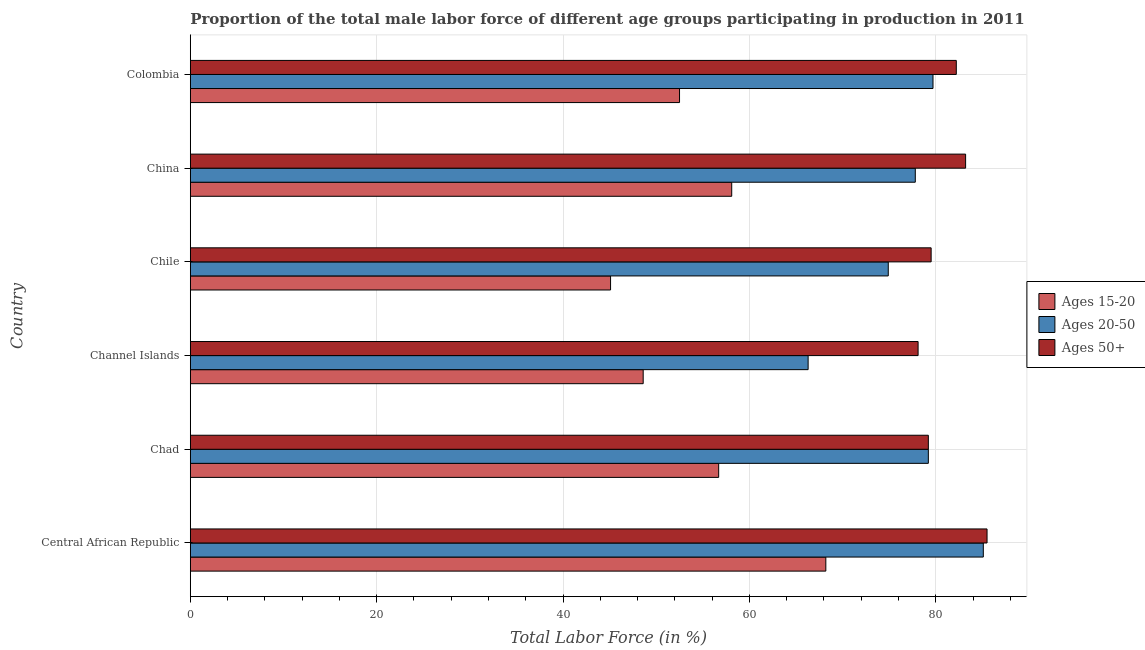How many bars are there on the 1st tick from the top?
Offer a terse response. 3. In how many cases, is the number of bars for a given country not equal to the number of legend labels?
Your response must be concise. 0. What is the percentage of male labor force within the age group 15-20 in Colombia?
Your answer should be very brief. 52.5. Across all countries, what is the maximum percentage of male labor force above age 50?
Make the answer very short. 85.5. Across all countries, what is the minimum percentage of male labor force above age 50?
Give a very brief answer. 78.1. In which country was the percentage of male labor force within the age group 15-20 maximum?
Keep it short and to the point. Central African Republic. In which country was the percentage of male labor force within the age group 20-50 minimum?
Your answer should be compact. Channel Islands. What is the total percentage of male labor force above age 50 in the graph?
Provide a succinct answer. 487.7. What is the difference between the percentage of male labor force above age 50 in Central African Republic and the percentage of male labor force within the age group 20-50 in Channel Islands?
Give a very brief answer. 19.2. What is the average percentage of male labor force within the age group 15-20 per country?
Offer a terse response. 54.87. What is the difference between the percentage of male labor force within the age group 15-20 and percentage of male labor force within the age group 20-50 in China?
Offer a very short reply. -19.7. What is the ratio of the percentage of male labor force within the age group 15-20 in Central African Republic to that in Chile?
Offer a terse response. 1.51. What is the difference between the highest and the second highest percentage of male labor force within the age group 15-20?
Make the answer very short. 10.1. What is the difference between the highest and the lowest percentage of male labor force within the age group 20-50?
Your answer should be compact. 18.8. In how many countries, is the percentage of male labor force within the age group 20-50 greater than the average percentage of male labor force within the age group 20-50 taken over all countries?
Give a very brief answer. 4. What does the 1st bar from the top in China represents?
Offer a very short reply. Ages 50+. What does the 1st bar from the bottom in China represents?
Keep it short and to the point. Ages 15-20. Is it the case that in every country, the sum of the percentage of male labor force within the age group 15-20 and percentage of male labor force within the age group 20-50 is greater than the percentage of male labor force above age 50?
Provide a short and direct response. Yes. Are all the bars in the graph horizontal?
Offer a very short reply. Yes. Does the graph contain grids?
Make the answer very short. Yes. Where does the legend appear in the graph?
Provide a short and direct response. Center right. How many legend labels are there?
Make the answer very short. 3. How are the legend labels stacked?
Make the answer very short. Vertical. What is the title of the graph?
Provide a succinct answer. Proportion of the total male labor force of different age groups participating in production in 2011. Does "Resident buildings and public services" appear as one of the legend labels in the graph?
Your answer should be compact. No. What is the label or title of the X-axis?
Offer a very short reply. Total Labor Force (in %). What is the label or title of the Y-axis?
Offer a very short reply. Country. What is the Total Labor Force (in %) of Ages 15-20 in Central African Republic?
Provide a short and direct response. 68.2. What is the Total Labor Force (in %) of Ages 20-50 in Central African Republic?
Provide a short and direct response. 85.1. What is the Total Labor Force (in %) of Ages 50+ in Central African Republic?
Ensure brevity in your answer.  85.5. What is the Total Labor Force (in %) of Ages 15-20 in Chad?
Provide a succinct answer. 56.7. What is the Total Labor Force (in %) of Ages 20-50 in Chad?
Provide a short and direct response. 79.2. What is the Total Labor Force (in %) in Ages 50+ in Chad?
Keep it short and to the point. 79.2. What is the Total Labor Force (in %) of Ages 15-20 in Channel Islands?
Offer a very short reply. 48.6. What is the Total Labor Force (in %) of Ages 20-50 in Channel Islands?
Offer a very short reply. 66.3. What is the Total Labor Force (in %) of Ages 50+ in Channel Islands?
Your answer should be very brief. 78.1. What is the Total Labor Force (in %) of Ages 15-20 in Chile?
Keep it short and to the point. 45.1. What is the Total Labor Force (in %) in Ages 20-50 in Chile?
Provide a succinct answer. 74.9. What is the Total Labor Force (in %) of Ages 50+ in Chile?
Keep it short and to the point. 79.5. What is the Total Labor Force (in %) of Ages 15-20 in China?
Offer a very short reply. 58.1. What is the Total Labor Force (in %) of Ages 20-50 in China?
Ensure brevity in your answer.  77.8. What is the Total Labor Force (in %) of Ages 50+ in China?
Make the answer very short. 83.2. What is the Total Labor Force (in %) of Ages 15-20 in Colombia?
Ensure brevity in your answer.  52.5. What is the Total Labor Force (in %) of Ages 20-50 in Colombia?
Provide a succinct answer. 79.7. What is the Total Labor Force (in %) of Ages 50+ in Colombia?
Your answer should be very brief. 82.2. Across all countries, what is the maximum Total Labor Force (in %) in Ages 15-20?
Provide a short and direct response. 68.2. Across all countries, what is the maximum Total Labor Force (in %) in Ages 20-50?
Your response must be concise. 85.1. Across all countries, what is the maximum Total Labor Force (in %) in Ages 50+?
Your answer should be compact. 85.5. Across all countries, what is the minimum Total Labor Force (in %) in Ages 15-20?
Your answer should be compact. 45.1. Across all countries, what is the minimum Total Labor Force (in %) in Ages 20-50?
Ensure brevity in your answer.  66.3. Across all countries, what is the minimum Total Labor Force (in %) of Ages 50+?
Provide a succinct answer. 78.1. What is the total Total Labor Force (in %) of Ages 15-20 in the graph?
Your answer should be very brief. 329.2. What is the total Total Labor Force (in %) of Ages 20-50 in the graph?
Make the answer very short. 463. What is the total Total Labor Force (in %) in Ages 50+ in the graph?
Ensure brevity in your answer.  487.7. What is the difference between the Total Labor Force (in %) in Ages 15-20 in Central African Republic and that in Chad?
Give a very brief answer. 11.5. What is the difference between the Total Labor Force (in %) in Ages 20-50 in Central African Republic and that in Chad?
Your answer should be compact. 5.9. What is the difference between the Total Labor Force (in %) of Ages 50+ in Central African Republic and that in Chad?
Provide a succinct answer. 6.3. What is the difference between the Total Labor Force (in %) of Ages 15-20 in Central African Republic and that in Channel Islands?
Ensure brevity in your answer.  19.6. What is the difference between the Total Labor Force (in %) of Ages 15-20 in Central African Republic and that in Chile?
Ensure brevity in your answer.  23.1. What is the difference between the Total Labor Force (in %) in Ages 20-50 in Central African Republic and that in Chile?
Provide a succinct answer. 10.2. What is the difference between the Total Labor Force (in %) of Ages 15-20 in Central African Republic and that in China?
Your answer should be compact. 10.1. What is the difference between the Total Labor Force (in %) in Ages 20-50 in Central African Republic and that in China?
Offer a very short reply. 7.3. What is the difference between the Total Labor Force (in %) in Ages 20-50 in Central African Republic and that in Colombia?
Provide a short and direct response. 5.4. What is the difference between the Total Labor Force (in %) in Ages 15-20 in Chad and that in Channel Islands?
Offer a very short reply. 8.1. What is the difference between the Total Labor Force (in %) of Ages 20-50 in Chad and that in China?
Ensure brevity in your answer.  1.4. What is the difference between the Total Labor Force (in %) in Ages 50+ in Chad and that in China?
Give a very brief answer. -4. What is the difference between the Total Labor Force (in %) of Ages 15-20 in Chad and that in Colombia?
Your response must be concise. 4.2. What is the difference between the Total Labor Force (in %) of Ages 15-20 in Channel Islands and that in Chile?
Offer a terse response. 3.5. What is the difference between the Total Labor Force (in %) in Ages 15-20 in Channel Islands and that in China?
Ensure brevity in your answer.  -9.5. What is the difference between the Total Labor Force (in %) in Ages 20-50 in Channel Islands and that in China?
Keep it short and to the point. -11.5. What is the difference between the Total Labor Force (in %) in Ages 15-20 in Chile and that in China?
Provide a short and direct response. -13. What is the difference between the Total Labor Force (in %) in Ages 15-20 in Chile and that in Colombia?
Make the answer very short. -7.4. What is the difference between the Total Labor Force (in %) of Ages 15-20 in China and that in Colombia?
Offer a very short reply. 5.6. What is the difference between the Total Labor Force (in %) in Ages 20-50 in China and that in Colombia?
Provide a short and direct response. -1.9. What is the difference between the Total Labor Force (in %) of Ages 15-20 in Central African Republic and the Total Labor Force (in %) of Ages 20-50 in Chad?
Offer a very short reply. -11. What is the difference between the Total Labor Force (in %) of Ages 15-20 in Central African Republic and the Total Labor Force (in %) of Ages 50+ in Channel Islands?
Your answer should be very brief. -9.9. What is the difference between the Total Labor Force (in %) in Ages 15-20 in Central African Republic and the Total Labor Force (in %) in Ages 50+ in Chile?
Ensure brevity in your answer.  -11.3. What is the difference between the Total Labor Force (in %) in Ages 20-50 in Central African Republic and the Total Labor Force (in %) in Ages 50+ in Chile?
Your response must be concise. 5.6. What is the difference between the Total Labor Force (in %) in Ages 15-20 in Central African Republic and the Total Labor Force (in %) in Ages 20-50 in China?
Your answer should be very brief. -9.6. What is the difference between the Total Labor Force (in %) in Ages 15-20 in Central African Republic and the Total Labor Force (in %) in Ages 50+ in China?
Your answer should be compact. -15. What is the difference between the Total Labor Force (in %) of Ages 15-20 in Central African Republic and the Total Labor Force (in %) of Ages 20-50 in Colombia?
Your response must be concise. -11.5. What is the difference between the Total Labor Force (in %) of Ages 15-20 in Central African Republic and the Total Labor Force (in %) of Ages 50+ in Colombia?
Ensure brevity in your answer.  -14. What is the difference between the Total Labor Force (in %) of Ages 20-50 in Central African Republic and the Total Labor Force (in %) of Ages 50+ in Colombia?
Provide a succinct answer. 2.9. What is the difference between the Total Labor Force (in %) in Ages 15-20 in Chad and the Total Labor Force (in %) in Ages 50+ in Channel Islands?
Offer a terse response. -21.4. What is the difference between the Total Labor Force (in %) of Ages 20-50 in Chad and the Total Labor Force (in %) of Ages 50+ in Channel Islands?
Your answer should be compact. 1.1. What is the difference between the Total Labor Force (in %) in Ages 15-20 in Chad and the Total Labor Force (in %) in Ages 20-50 in Chile?
Your response must be concise. -18.2. What is the difference between the Total Labor Force (in %) of Ages 15-20 in Chad and the Total Labor Force (in %) of Ages 50+ in Chile?
Provide a succinct answer. -22.8. What is the difference between the Total Labor Force (in %) in Ages 15-20 in Chad and the Total Labor Force (in %) in Ages 20-50 in China?
Your answer should be compact. -21.1. What is the difference between the Total Labor Force (in %) in Ages 15-20 in Chad and the Total Labor Force (in %) in Ages 50+ in China?
Your answer should be compact. -26.5. What is the difference between the Total Labor Force (in %) in Ages 15-20 in Chad and the Total Labor Force (in %) in Ages 50+ in Colombia?
Ensure brevity in your answer.  -25.5. What is the difference between the Total Labor Force (in %) in Ages 15-20 in Channel Islands and the Total Labor Force (in %) in Ages 20-50 in Chile?
Give a very brief answer. -26.3. What is the difference between the Total Labor Force (in %) in Ages 15-20 in Channel Islands and the Total Labor Force (in %) in Ages 50+ in Chile?
Ensure brevity in your answer.  -30.9. What is the difference between the Total Labor Force (in %) in Ages 20-50 in Channel Islands and the Total Labor Force (in %) in Ages 50+ in Chile?
Provide a succinct answer. -13.2. What is the difference between the Total Labor Force (in %) in Ages 15-20 in Channel Islands and the Total Labor Force (in %) in Ages 20-50 in China?
Provide a short and direct response. -29.2. What is the difference between the Total Labor Force (in %) of Ages 15-20 in Channel Islands and the Total Labor Force (in %) of Ages 50+ in China?
Your answer should be compact. -34.6. What is the difference between the Total Labor Force (in %) of Ages 20-50 in Channel Islands and the Total Labor Force (in %) of Ages 50+ in China?
Your response must be concise. -16.9. What is the difference between the Total Labor Force (in %) of Ages 15-20 in Channel Islands and the Total Labor Force (in %) of Ages 20-50 in Colombia?
Give a very brief answer. -31.1. What is the difference between the Total Labor Force (in %) of Ages 15-20 in Channel Islands and the Total Labor Force (in %) of Ages 50+ in Colombia?
Provide a short and direct response. -33.6. What is the difference between the Total Labor Force (in %) of Ages 20-50 in Channel Islands and the Total Labor Force (in %) of Ages 50+ in Colombia?
Offer a terse response. -15.9. What is the difference between the Total Labor Force (in %) in Ages 15-20 in Chile and the Total Labor Force (in %) in Ages 20-50 in China?
Your answer should be compact. -32.7. What is the difference between the Total Labor Force (in %) of Ages 15-20 in Chile and the Total Labor Force (in %) of Ages 50+ in China?
Provide a succinct answer. -38.1. What is the difference between the Total Labor Force (in %) of Ages 15-20 in Chile and the Total Labor Force (in %) of Ages 20-50 in Colombia?
Your answer should be compact. -34.6. What is the difference between the Total Labor Force (in %) in Ages 15-20 in Chile and the Total Labor Force (in %) in Ages 50+ in Colombia?
Ensure brevity in your answer.  -37.1. What is the difference between the Total Labor Force (in %) in Ages 20-50 in Chile and the Total Labor Force (in %) in Ages 50+ in Colombia?
Provide a short and direct response. -7.3. What is the difference between the Total Labor Force (in %) of Ages 15-20 in China and the Total Labor Force (in %) of Ages 20-50 in Colombia?
Give a very brief answer. -21.6. What is the difference between the Total Labor Force (in %) in Ages 15-20 in China and the Total Labor Force (in %) in Ages 50+ in Colombia?
Provide a succinct answer. -24.1. What is the average Total Labor Force (in %) of Ages 15-20 per country?
Your answer should be compact. 54.87. What is the average Total Labor Force (in %) of Ages 20-50 per country?
Your answer should be compact. 77.17. What is the average Total Labor Force (in %) of Ages 50+ per country?
Make the answer very short. 81.28. What is the difference between the Total Labor Force (in %) of Ages 15-20 and Total Labor Force (in %) of Ages 20-50 in Central African Republic?
Your answer should be very brief. -16.9. What is the difference between the Total Labor Force (in %) of Ages 15-20 and Total Labor Force (in %) of Ages 50+ in Central African Republic?
Offer a terse response. -17.3. What is the difference between the Total Labor Force (in %) in Ages 20-50 and Total Labor Force (in %) in Ages 50+ in Central African Republic?
Your answer should be very brief. -0.4. What is the difference between the Total Labor Force (in %) of Ages 15-20 and Total Labor Force (in %) of Ages 20-50 in Chad?
Ensure brevity in your answer.  -22.5. What is the difference between the Total Labor Force (in %) in Ages 15-20 and Total Labor Force (in %) in Ages 50+ in Chad?
Offer a very short reply. -22.5. What is the difference between the Total Labor Force (in %) in Ages 20-50 and Total Labor Force (in %) in Ages 50+ in Chad?
Your answer should be very brief. 0. What is the difference between the Total Labor Force (in %) in Ages 15-20 and Total Labor Force (in %) in Ages 20-50 in Channel Islands?
Keep it short and to the point. -17.7. What is the difference between the Total Labor Force (in %) in Ages 15-20 and Total Labor Force (in %) in Ages 50+ in Channel Islands?
Offer a very short reply. -29.5. What is the difference between the Total Labor Force (in %) of Ages 15-20 and Total Labor Force (in %) of Ages 20-50 in Chile?
Your response must be concise. -29.8. What is the difference between the Total Labor Force (in %) in Ages 15-20 and Total Labor Force (in %) in Ages 50+ in Chile?
Offer a very short reply. -34.4. What is the difference between the Total Labor Force (in %) of Ages 15-20 and Total Labor Force (in %) of Ages 20-50 in China?
Ensure brevity in your answer.  -19.7. What is the difference between the Total Labor Force (in %) in Ages 15-20 and Total Labor Force (in %) in Ages 50+ in China?
Make the answer very short. -25.1. What is the difference between the Total Labor Force (in %) of Ages 15-20 and Total Labor Force (in %) of Ages 20-50 in Colombia?
Provide a short and direct response. -27.2. What is the difference between the Total Labor Force (in %) in Ages 15-20 and Total Labor Force (in %) in Ages 50+ in Colombia?
Your response must be concise. -29.7. What is the ratio of the Total Labor Force (in %) of Ages 15-20 in Central African Republic to that in Chad?
Ensure brevity in your answer.  1.2. What is the ratio of the Total Labor Force (in %) of Ages 20-50 in Central African Republic to that in Chad?
Keep it short and to the point. 1.07. What is the ratio of the Total Labor Force (in %) in Ages 50+ in Central African Republic to that in Chad?
Make the answer very short. 1.08. What is the ratio of the Total Labor Force (in %) of Ages 15-20 in Central African Republic to that in Channel Islands?
Provide a short and direct response. 1.4. What is the ratio of the Total Labor Force (in %) in Ages 20-50 in Central African Republic to that in Channel Islands?
Provide a succinct answer. 1.28. What is the ratio of the Total Labor Force (in %) of Ages 50+ in Central African Republic to that in Channel Islands?
Provide a succinct answer. 1.09. What is the ratio of the Total Labor Force (in %) of Ages 15-20 in Central African Republic to that in Chile?
Offer a terse response. 1.51. What is the ratio of the Total Labor Force (in %) of Ages 20-50 in Central African Republic to that in Chile?
Ensure brevity in your answer.  1.14. What is the ratio of the Total Labor Force (in %) of Ages 50+ in Central African Republic to that in Chile?
Offer a terse response. 1.08. What is the ratio of the Total Labor Force (in %) of Ages 15-20 in Central African Republic to that in China?
Ensure brevity in your answer.  1.17. What is the ratio of the Total Labor Force (in %) of Ages 20-50 in Central African Republic to that in China?
Your response must be concise. 1.09. What is the ratio of the Total Labor Force (in %) in Ages 50+ in Central African Republic to that in China?
Make the answer very short. 1.03. What is the ratio of the Total Labor Force (in %) of Ages 15-20 in Central African Republic to that in Colombia?
Your answer should be very brief. 1.3. What is the ratio of the Total Labor Force (in %) in Ages 20-50 in Central African Republic to that in Colombia?
Your answer should be very brief. 1.07. What is the ratio of the Total Labor Force (in %) in Ages 50+ in Central African Republic to that in Colombia?
Offer a terse response. 1.04. What is the ratio of the Total Labor Force (in %) in Ages 20-50 in Chad to that in Channel Islands?
Keep it short and to the point. 1.19. What is the ratio of the Total Labor Force (in %) of Ages 50+ in Chad to that in Channel Islands?
Offer a terse response. 1.01. What is the ratio of the Total Labor Force (in %) of Ages 15-20 in Chad to that in Chile?
Make the answer very short. 1.26. What is the ratio of the Total Labor Force (in %) of Ages 20-50 in Chad to that in Chile?
Ensure brevity in your answer.  1.06. What is the ratio of the Total Labor Force (in %) of Ages 50+ in Chad to that in Chile?
Your answer should be very brief. 1. What is the ratio of the Total Labor Force (in %) of Ages 15-20 in Chad to that in China?
Your answer should be compact. 0.98. What is the ratio of the Total Labor Force (in %) in Ages 50+ in Chad to that in China?
Your response must be concise. 0.95. What is the ratio of the Total Labor Force (in %) in Ages 15-20 in Chad to that in Colombia?
Your answer should be very brief. 1.08. What is the ratio of the Total Labor Force (in %) in Ages 50+ in Chad to that in Colombia?
Your answer should be compact. 0.96. What is the ratio of the Total Labor Force (in %) of Ages 15-20 in Channel Islands to that in Chile?
Give a very brief answer. 1.08. What is the ratio of the Total Labor Force (in %) in Ages 20-50 in Channel Islands to that in Chile?
Provide a succinct answer. 0.89. What is the ratio of the Total Labor Force (in %) in Ages 50+ in Channel Islands to that in Chile?
Your answer should be very brief. 0.98. What is the ratio of the Total Labor Force (in %) of Ages 15-20 in Channel Islands to that in China?
Provide a succinct answer. 0.84. What is the ratio of the Total Labor Force (in %) of Ages 20-50 in Channel Islands to that in China?
Ensure brevity in your answer.  0.85. What is the ratio of the Total Labor Force (in %) of Ages 50+ in Channel Islands to that in China?
Keep it short and to the point. 0.94. What is the ratio of the Total Labor Force (in %) of Ages 15-20 in Channel Islands to that in Colombia?
Offer a very short reply. 0.93. What is the ratio of the Total Labor Force (in %) of Ages 20-50 in Channel Islands to that in Colombia?
Give a very brief answer. 0.83. What is the ratio of the Total Labor Force (in %) of Ages 50+ in Channel Islands to that in Colombia?
Provide a succinct answer. 0.95. What is the ratio of the Total Labor Force (in %) in Ages 15-20 in Chile to that in China?
Make the answer very short. 0.78. What is the ratio of the Total Labor Force (in %) of Ages 20-50 in Chile to that in China?
Your answer should be compact. 0.96. What is the ratio of the Total Labor Force (in %) of Ages 50+ in Chile to that in China?
Your answer should be very brief. 0.96. What is the ratio of the Total Labor Force (in %) of Ages 15-20 in Chile to that in Colombia?
Provide a succinct answer. 0.86. What is the ratio of the Total Labor Force (in %) of Ages 20-50 in Chile to that in Colombia?
Offer a terse response. 0.94. What is the ratio of the Total Labor Force (in %) in Ages 50+ in Chile to that in Colombia?
Ensure brevity in your answer.  0.97. What is the ratio of the Total Labor Force (in %) of Ages 15-20 in China to that in Colombia?
Keep it short and to the point. 1.11. What is the ratio of the Total Labor Force (in %) of Ages 20-50 in China to that in Colombia?
Make the answer very short. 0.98. What is the ratio of the Total Labor Force (in %) in Ages 50+ in China to that in Colombia?
Your answer should be compact. 1.01. What is the difference between the highest and the second highest Total Labor Force (in %) in Ages 15-20?
Your answer should be very brief. 10.1. What is the difference between the highest and the second highest Total Labor Force (in %) in Ages 50+?
Provide a succinct answer. 2.3. What is the difference between the highest and the lowest Total Labor Force (in %) in Ages 15-20?
Ensure brevity in your answer.  23.1. What is the difference between the highest and the lowest Total Labor Force (in %) in Ages 20-50?
Give a very brief answer. 18.8. What is the difference between the highest and the lowest Total Labor Force (in %) in Ages 50+?
Ensure brevity in your answer.  7.4. 